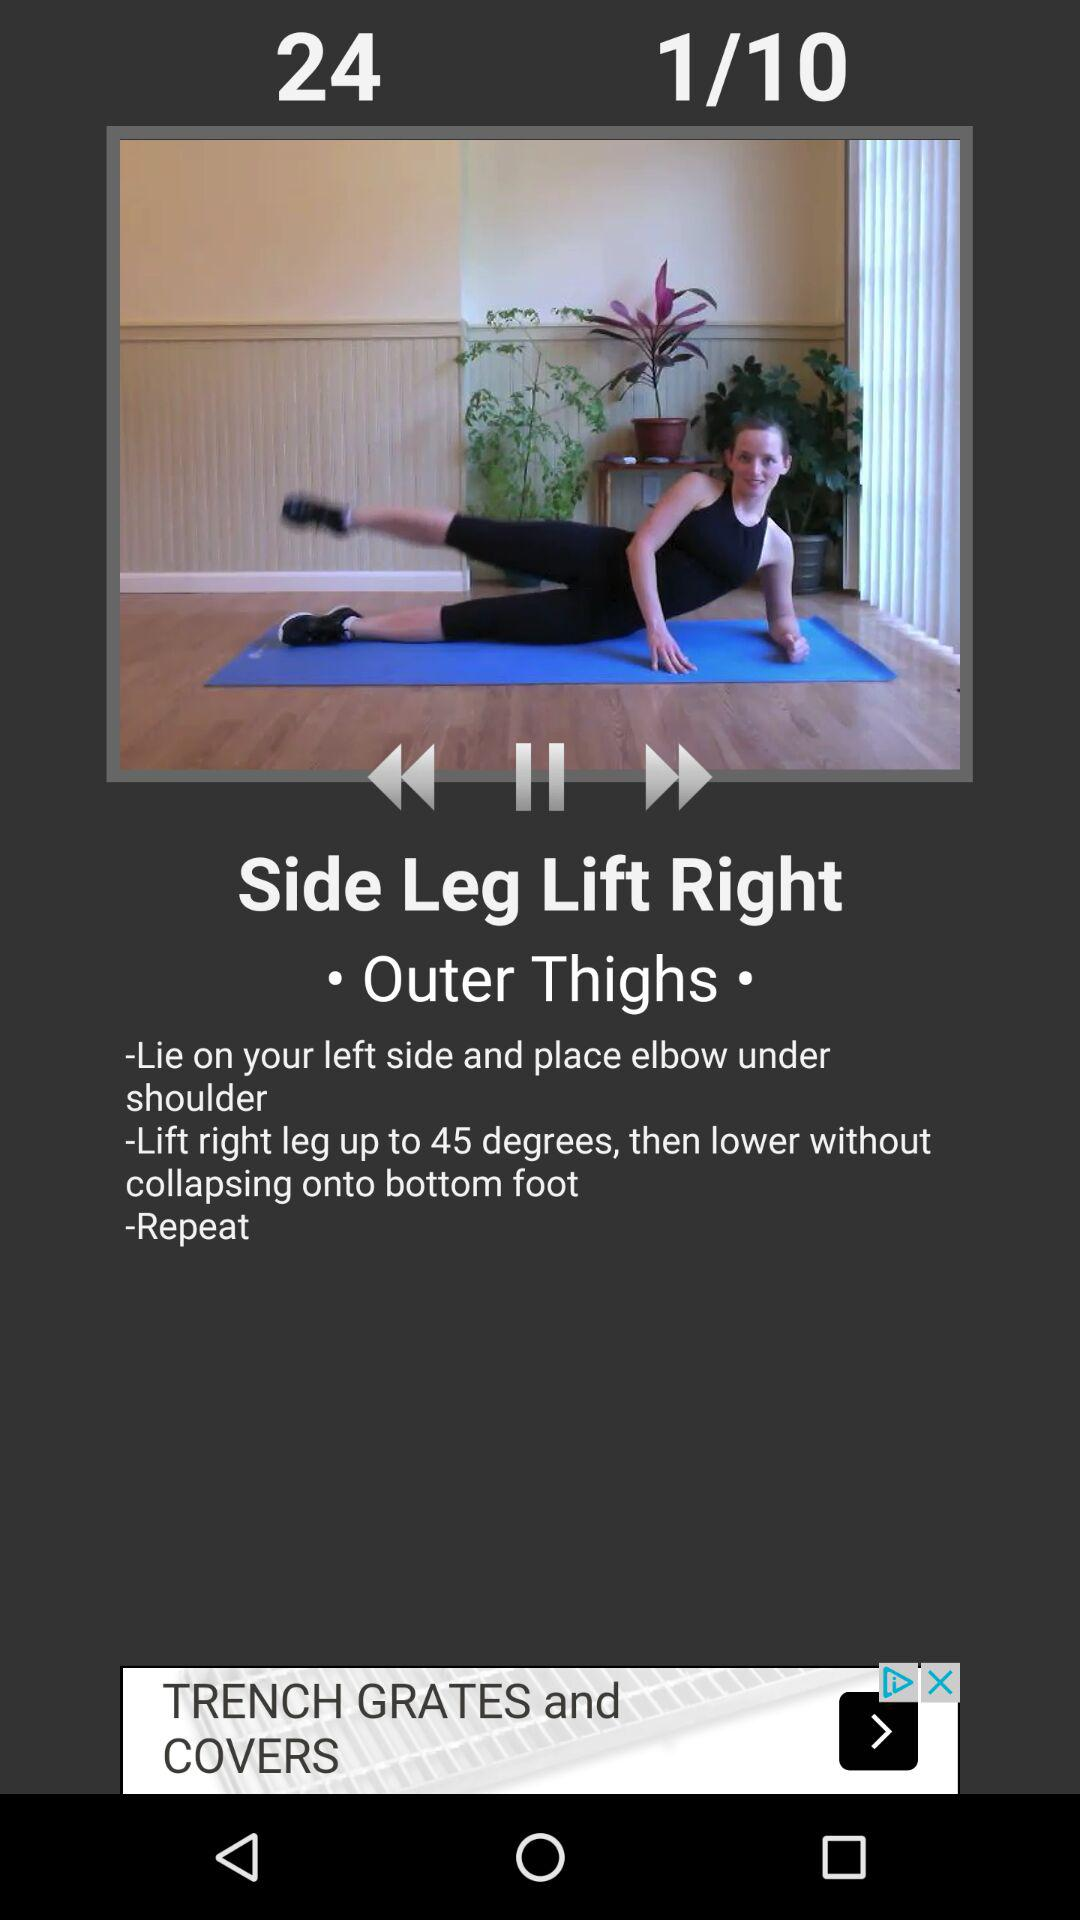How many instructions are there for this exercise?
Answer the question using a single word or phrase. 3 